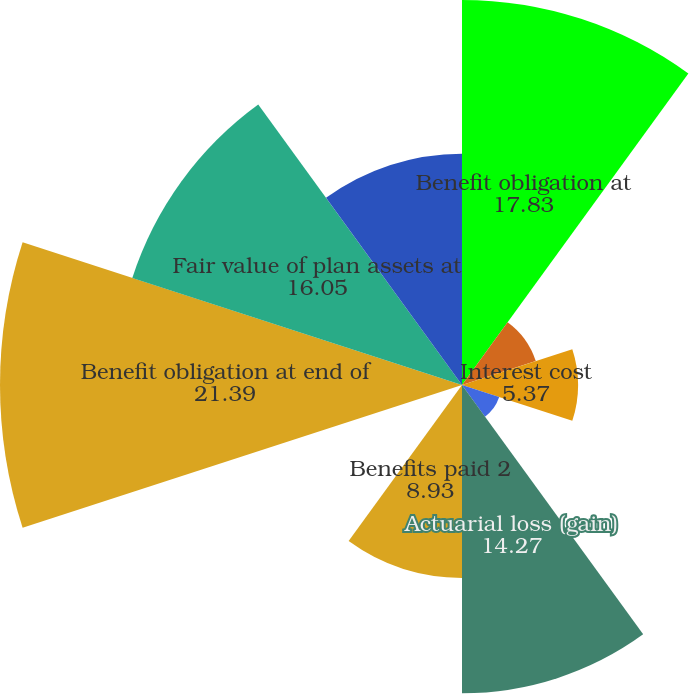Convert chart. <chart><loc_0><loc_0><loc_500><loc_500><pie_chart><fcel>Benefit obligation at<fcel>Service cost<fcel>Interest cost<fcel>Foreign currency exchange rate<fcel>Actuarial loss (gain)<fcel>Benefits paid 2<fcel>Other<fcel>Benefit obligation at end of<fcel>Fair value of plan assets at<fcel>Actual return on plan assets<nl><fcel>17.83%<fcel>3.59%<fcel>5.37%<fcel>1.81%<fcel>14.27%<fcel>8.93%<fcel>0.03%<fcel>21.39%<fcel>16.05%<fcel>10.71%<nl></chart> 